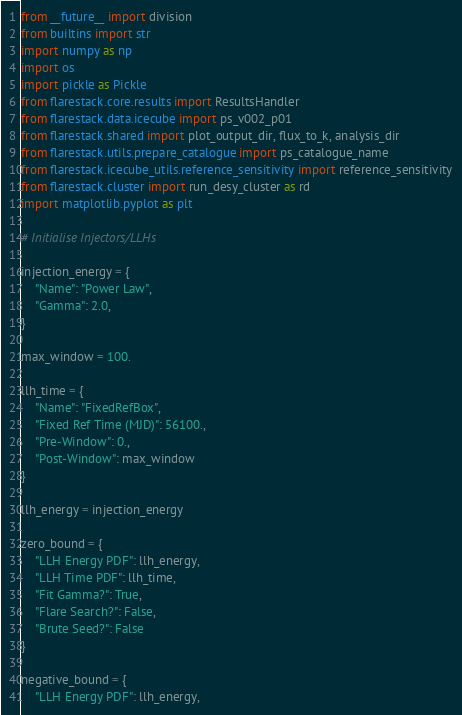Convert code to text. <code><loc_0><loc_0><loc_500><loc_500><_Python_>from __future__ import division
from builtins import str
import numpy as np
import os
import pickle as Pickle
from flarestack.core.results import ResultsHandler
from flarestack.data.icecube import ps_v002_p01
from flarestack.shared import plot_output_dir, flux_to_k, analysis_dir
from flarestack.utils.prepare_catalogue import ps_catalogue_name
from flarestack.icecube_utils.reference_sensitivity import reference_sensitivity
from flarestack.cluster import run_desy_cluster as rd
import matplotlib.pyplot as plt

# Initialise Injectors/LLHs

injection_energy = {
    "Name": "Power Law",
    "Gamma": 2.0,
}

max_window = 100.

llh_time = {
    "Name": "FixedRefBox",
    "Fixed Ref Time (MJD)": 56100.,
    "Pre-Window": 0.,
    "Post-Window": max_window
}

llh_energy = injection_energy

zero_bound = {
    "LLH Energy PDF": llh_energy,
    "LLH Time PDF": llh_time,
    "Fit Gamma?": True,
    "Flare Search?": False,
    "Brute Seed?": False
}

negative_bound = {
    "LLH Energy PDF": llh_energy,</code> 